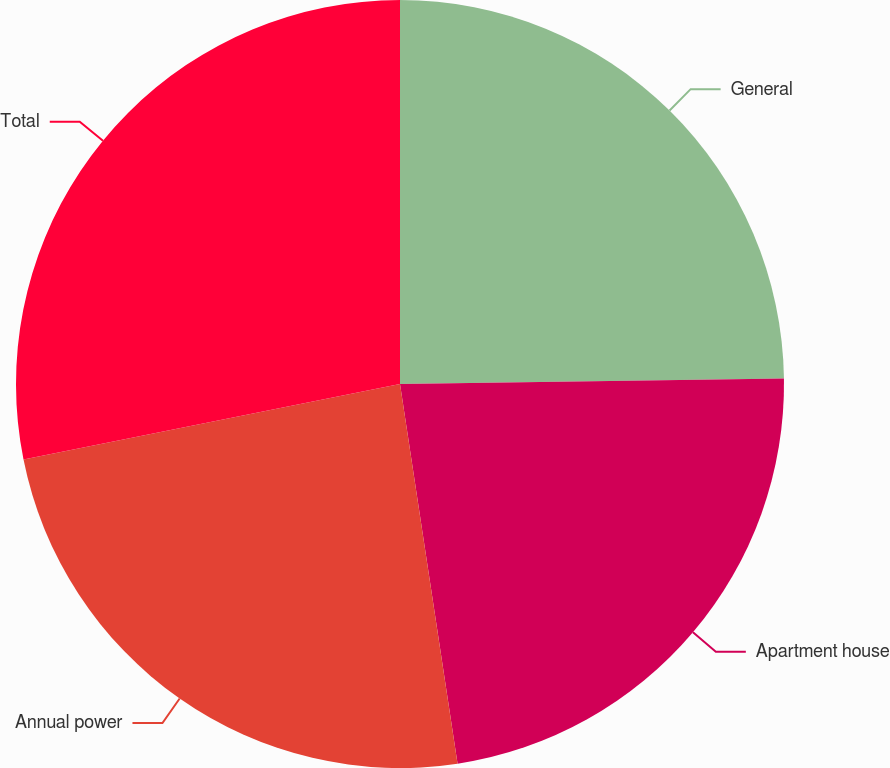Convert chart. <chart><loc_0><loc_0><loc_500><loc_500><pie_chart><fcel>General<fcel>Apartment house<fcel>Annual power<fcel>Total<nl><fcel>24.77%<fcel>22.83%<fcel>24.24%<fcel>28.15%<nl></chart> 